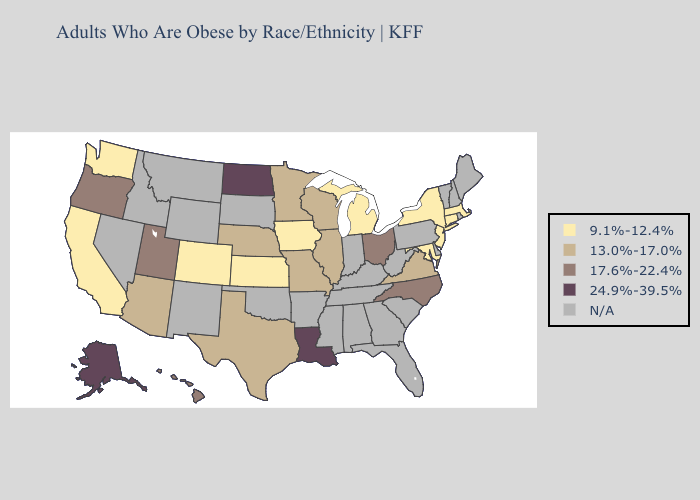What is the highest value in the USA?
Concise answer only. 24.9%-39.5%. Name the states that have a value in the range 17.6%-22.4%?
Be succinct. Hawaii, North Carolina, Ohio, Oregon, Utah. What is the highest value in the Northeast ?
Give a very brief answer. 9.1%-12.4%. What is the lowest value in states that border New Mexico?
Be succinct. 9.1%-12.4%. Name the states that have a value in the range 9.1%-12.4%?
Quick response, please. California, Colorado, Connecticut, Iowa, Kansas, Maryland, Massachusetts, Michigan, New Jersey, New York, Washington. Among the states that border Ohio , which have the highest value?
Short answer required. Michigan. Does Virginia have the lowest value in the USA?
Quick response, please. No. Is the legend a continuous bar?
Be succinct. No. Name the states that have a value in the range 13.0%-17.0%?
Quick response, please. Arizona, Illinois, Minnesota, Missouri, Nebraska, Texas, Virginia, Wisconsin. Which states have the lowest value in the South?
Concise answer only. Maryland. Name the states that have a value in the range 24.9%-39.5%?
Answer briefly. Alaska, Louisiana, North Dakota. Among the states that border Nevada , does Utah have the highest value?
Concise answer only. Yes. 